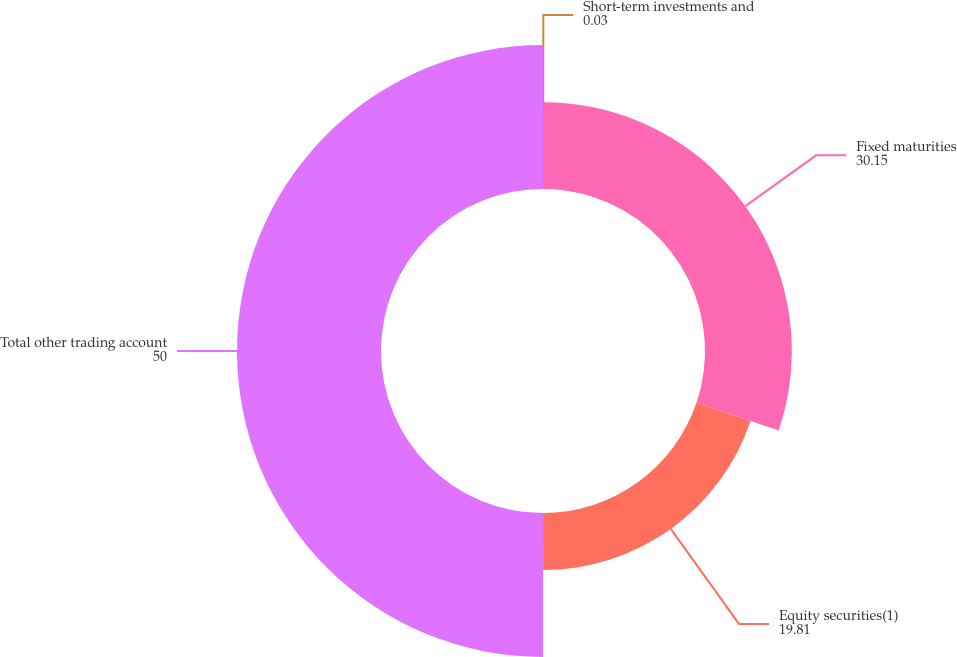<chart> <loc_0><loc_0><loc_500><loc_500><pie_chart><fcel>Short-term investments and<fcel>Fixed maturities<fcel>Equity securities(1)<fcel>Total other trading account<nl><fcel>0.03%<fcel>30.15%<fcel>19.81%<fcel>50.0%<nl></chart> 